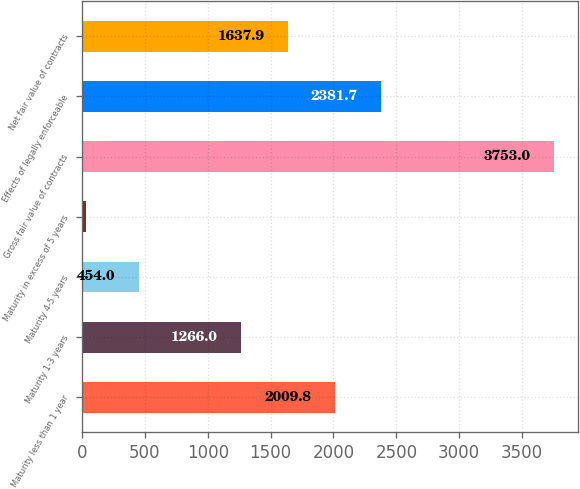Convert chart to OTSL. <chart><loc_0><loc_0><loc_500><loc_500><bar_chart><fcel>Maturity less than 1 year<fcel>Maturity 1-3 years<fcel>Maturity 4-5 years<fcel>Maturity in excess of 5 years<fcel>Gross fair value of contracts<fcel>Effects of legally enforceable<fcel>Net fair value of contracts<nl><fcel>2009.8<fcel>1266<fcel>454<fcel>34<fcel>3753<fcel>2381.7<fcel>1637.9<nl></chart> 